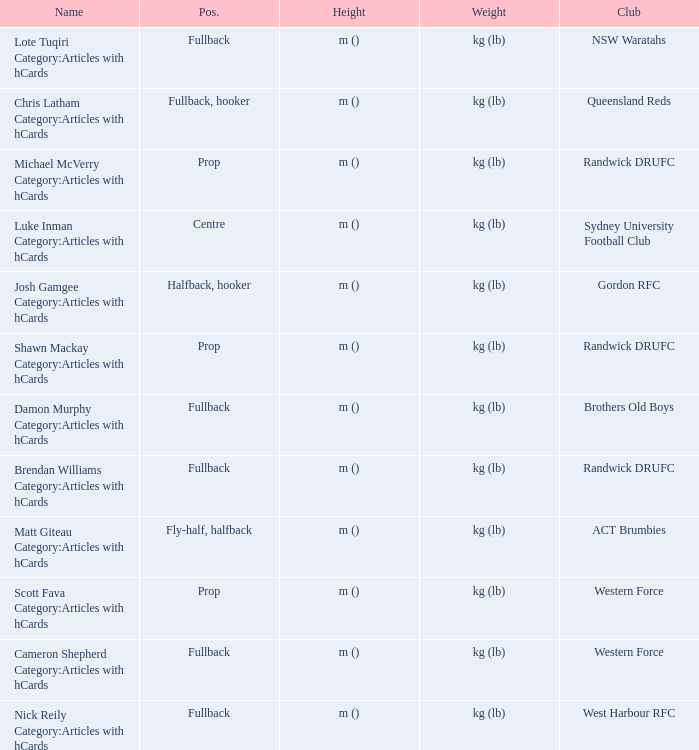What is the name when the position is centre? Luke Inman Category:Articles with hCards. Parse the table in full. {'header': ['Name', 'Pos.', 'Height', 'Weight', 'Club'], 'rows': [['Lote Tuqiri Category:Articles with hCards', 'Fullback', 'm ()', 'kg (lb)', 'NSW Waratahs'], ['Chris Latham Category:Articles with hCards', 'Fullback, hooker', 'm ()', 'kg (lb)', 'Queensland Reds'], ['Michael McVerry Category:Articles with hCards', 'Prop', 'm ()', 'kg (lb)', 'Randwick DRUFC'], ['Luke Inman Category:Articles with hCards', 'Centre', 'm ()', 'kg (lb)', 'Sydney University Football Club'], ['Josh Gamgee Category:Articles with hCards', 'Halfback, hooker', 'm ()', 'kg (lb)', 'Gordon RFC'], ['Shawn Mackay Category:Articles with hCards', 'Prop', 'm ()', 'kg (lb)', 'Randwick DRUFC'], ['Damon Murphy Category:Articles with hCards', 'Fullback', 'm ()', 'kg (lb)', 'Brothers Old Boys'], ['Brendan Williams Category:Articles with hCards', 'Fullback', 'm ()', 'kg (lb)', 'Randwick DRUFC'], ['Matt Giteau Category:Articles with hCards', 'Fly-half, halfback', 'm ()', 'kg (lb)', 'ACT Brumbies'], ['Scott Fava Category:Articles with hCards', 'Prop', 'm ()', 'kg (lb)', 'Western Force'], ['Cameron Shepherd Category:Articles with hCards', 'Fullback', 'm ()', 'kg (lb)', 'Western Force'], ['Nick Reily Category:Articles with hCards', 'Fullback', 'm ()', 'kg (lb)', 'West Harbour RFC']]} 